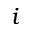Convert formula to latex. <formula><loc_0><loc_0><loc_500><loc_500>i</formula> 